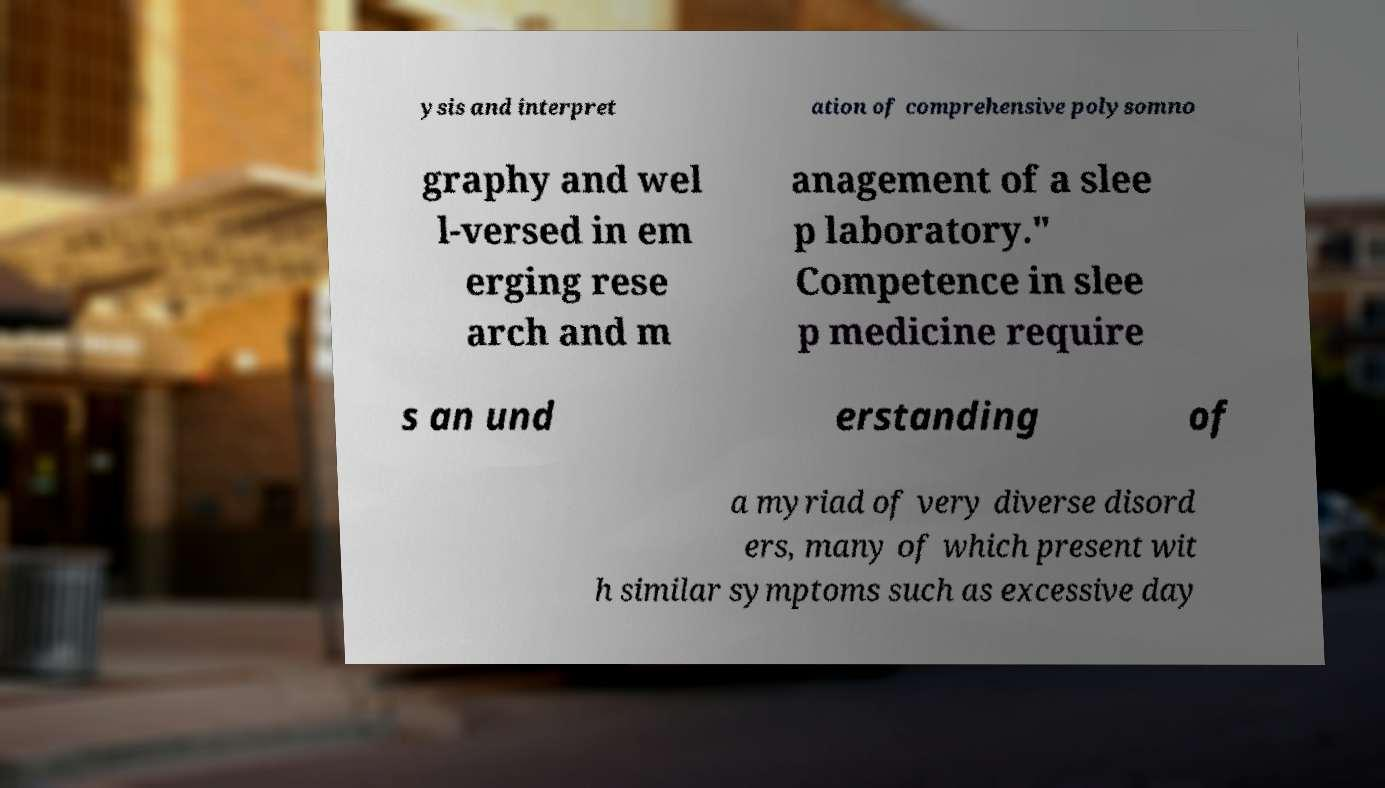Can you accurately transcribe the text from the provided image for me? ysis and interpret ation of comprehensive polysomno graphy and wel l-versed in em erging rese arch and m anagement of a slee p laboratory." Competence in slee p medicine require s an und erstanding of a myriad of very diverse disord ers, many of which present wit h similar symptoms such as excessive day 